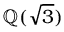Convert formula to latex. <formula><loc_0><loc_0><loc_500><loc_500>\mathbb { Q } ( { \sqrt { 3 } } )</formula> 